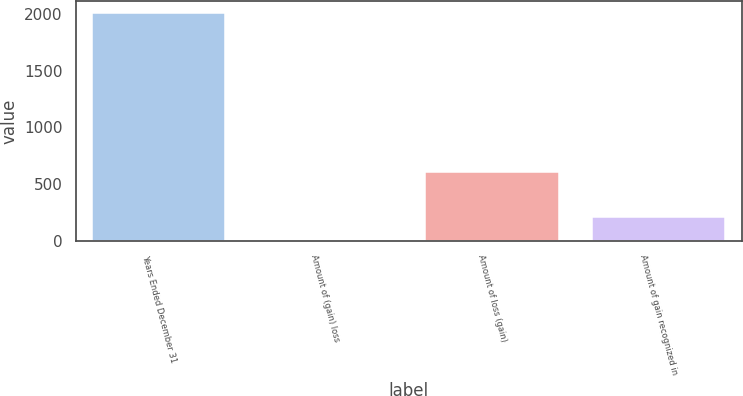Convert chart. <chart><loc_0><loc_0><loc_500><loc_500><bar_chart><fcel>Years Ended December 31<fcel>Amount of (gain) loss<fcel>Amount of loss (gain)<fcel>Amount of gain recognized in<nl><fcel>2013<fcel>8<fcel>609.5<fcel>208.5<nl></chart> 